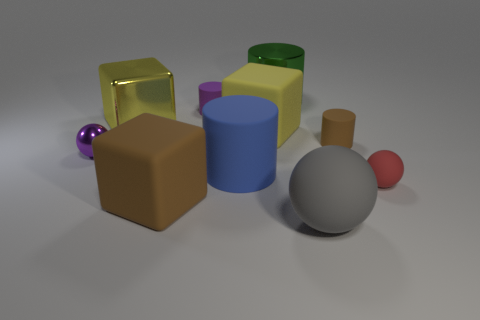Subtract all large metal cylinders. How many cylinders are left? 3 Subtract all brown cylinders. How many cylinders are left? 3 Subtract all blocks. How many objects are left? 7 Subtract 3 cubes. How many cubes are left? 0 Subtract all cyan spheres. Subtract all yellow cylinders. How many spheres are left? 3 Subtract all green blocks. How many brown balls are left? 0 Subtract all tiny brown matte cylinders. Subtract all big gray rubber things. How many objects are left? 8 Add 3 tiny red rubber things. How many tiny red rubber things are left? 4 Add 4 cylinders. How many cylinders exist? 8 Subtract 0 red cylinders. How many objects are left? 10 